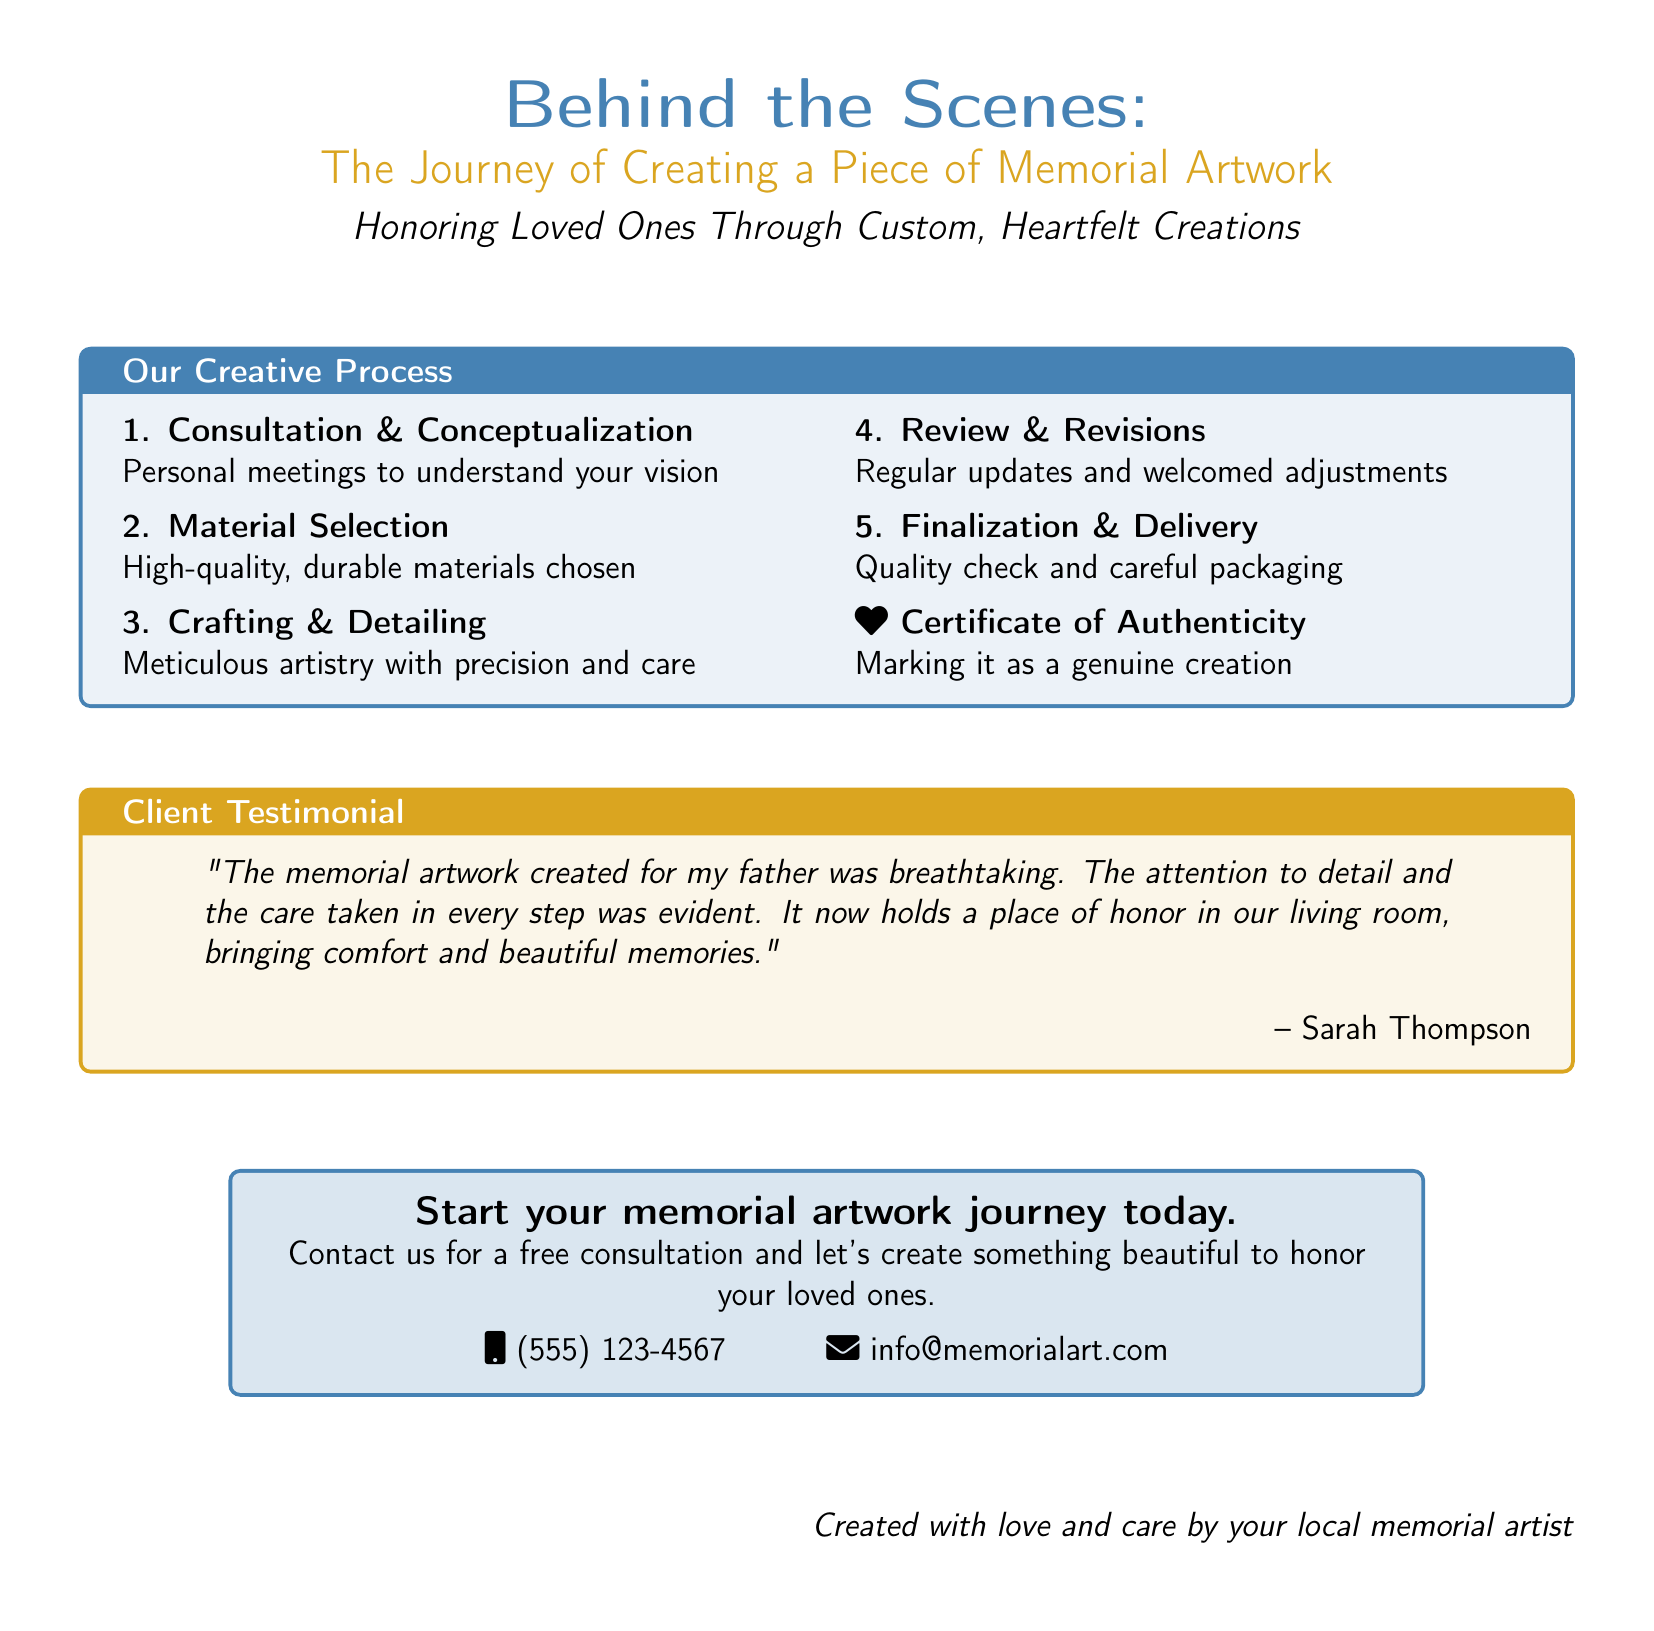What is the main title of the document? The main title is prominently displayed at the top of the document.
Answer: Behind the Scenes: The Journey of Creating a Piece of Memorial Artwork What is the purpose of the memorial artwork mentioned? The purpose is stated in the subtitle of the document, conveying the intent behind the artwork.
Answer: Honoring Loved Ones Through Custom, Heartfelt Creations How many steps are outlined in the creative process? The steps of the creative process are numbered and listed within the document.
Answer: Five What type of material is selected for the artwork? The document specifies the quality of materials chosen for crafting the artwork.
Answer: High-quality, durable materials Who provided a testimonial in the document? The testimonial includes the name of the person who experienced the service.
Answer: Sarah Thompson What is included with the final artwork? The document mentions an additional credential that accompanies the finished piece.
Answer: Certificate of Authenticity What aspect of the service does the testimonial focus on? The testimonial reflects on a specific characteristic of the memorial artwork creation.
Answer: Attention to detail How can one start their memorial artwork journey? The document provides a specific call to action near the end.
Answer: Contact us for a free consultation What color is used for the background of the main title? The document specifies the color associated with the main title section.
Answer: Artblue 